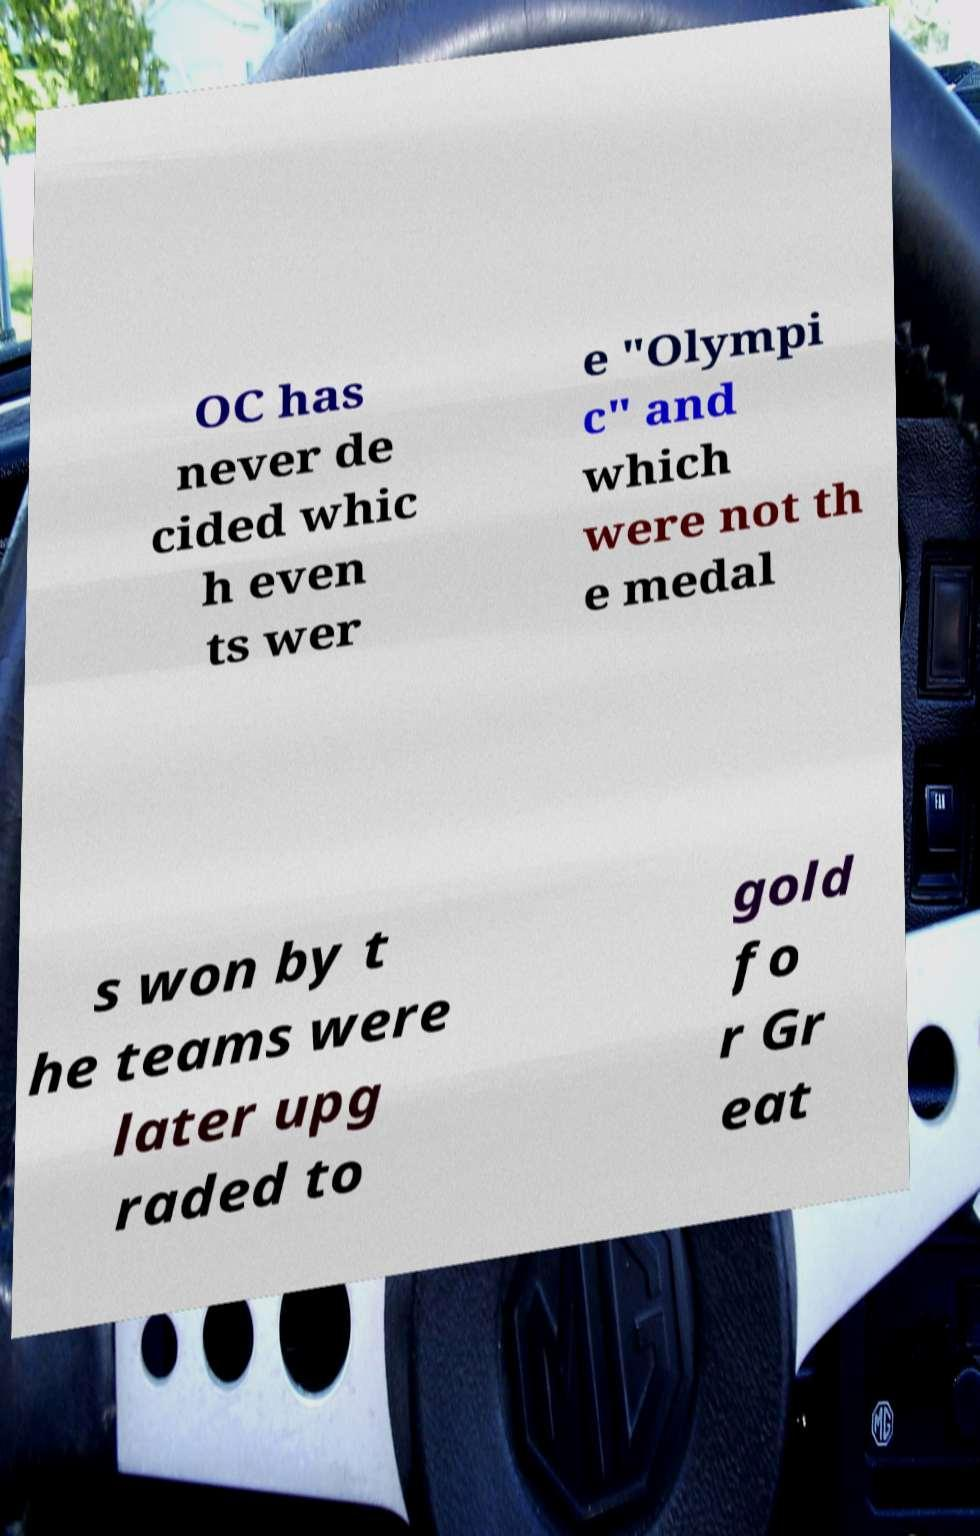Can you read and provide the text displayed in the image?This photo seems to have some interesting text. Can you extract and type it out for me? OC has never de cided whic h even ts wer e "Olympi c" and which were not th e medal s won by t he teams were later upg raded to gold fo r Gr eat 